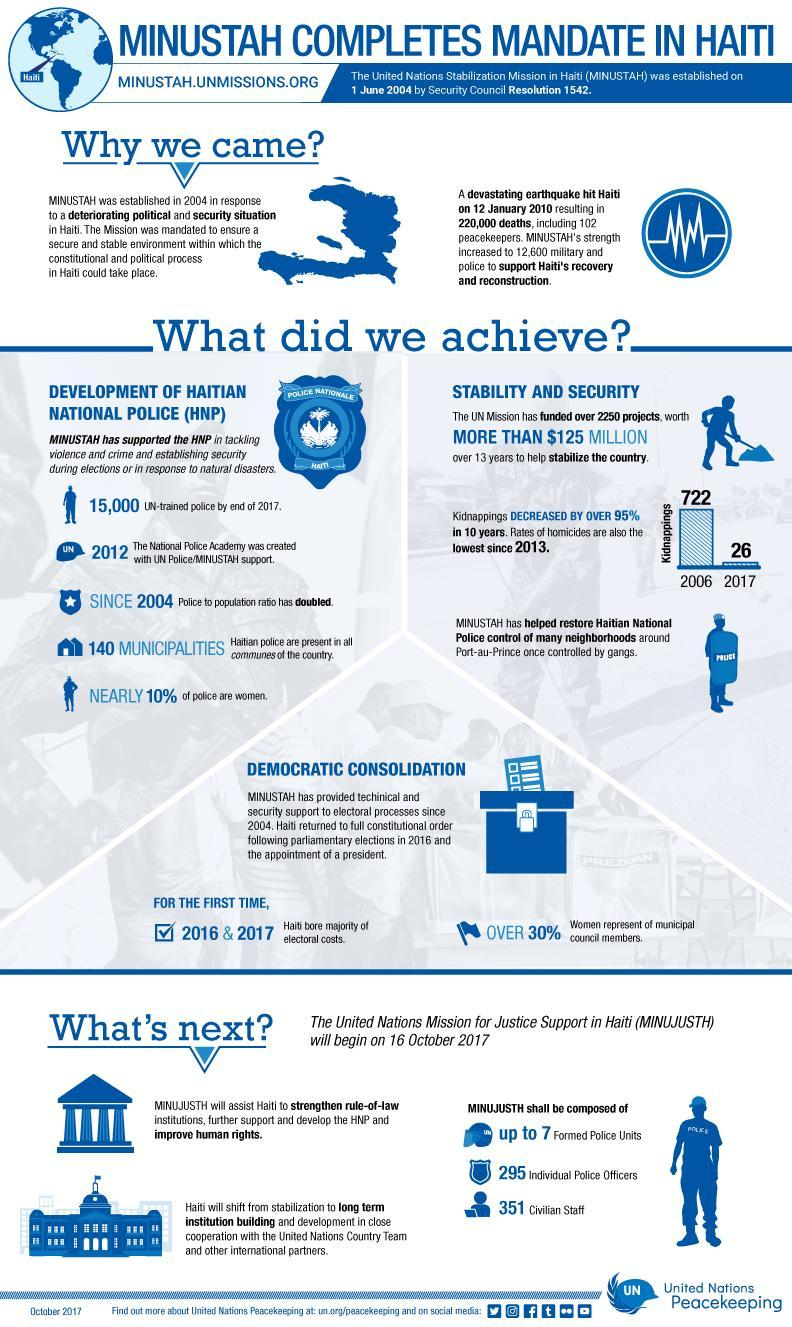How many peacekeepers died in the earthquake?
Answer the question with a short phrase. 102 When was Haiti hit by a big earthquake? 2010 Why was the strength of MINUSTAH increased in 2010? to support Haiti's recovery and reconstruction How many people died in the earthquake? 220,000 Which new mission will help to improve human rights in Haiti? MINUJUSTH What did UN do to help stabilize the country? funded over 2250 projects 